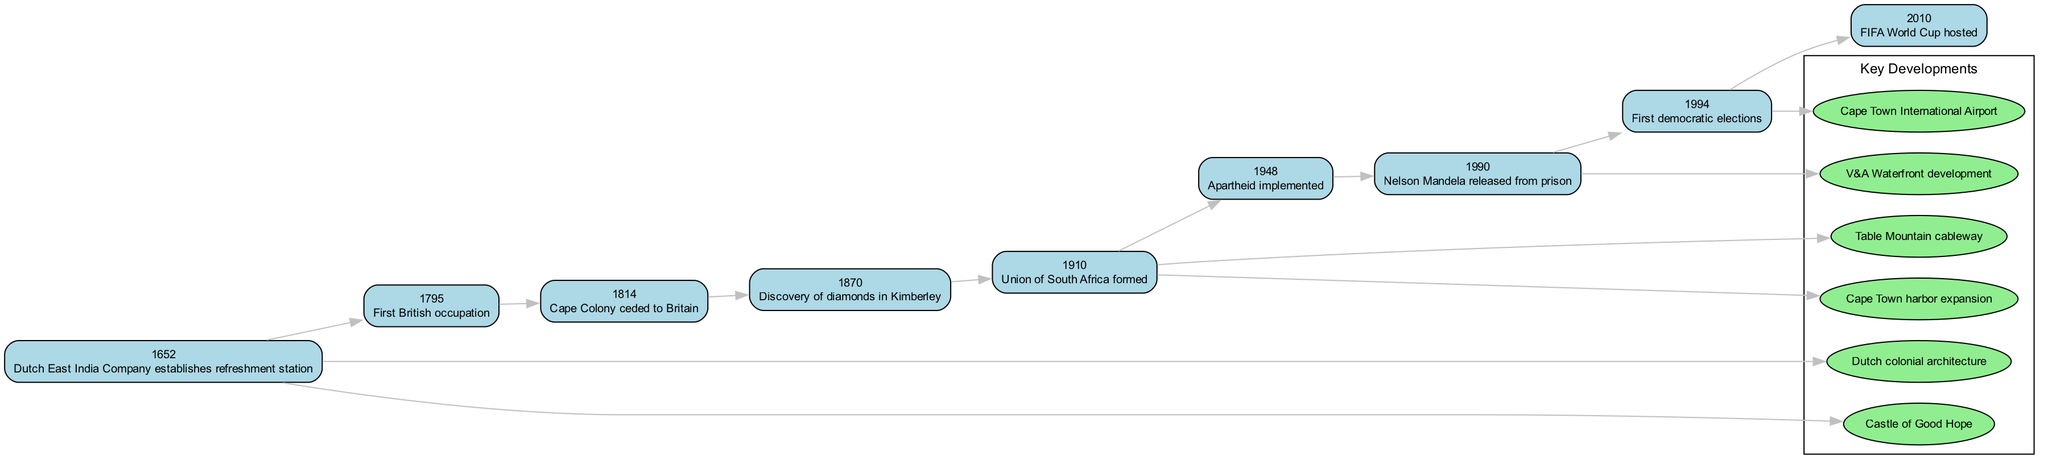What year did the Dutch East India Company establish the refreshment station? The event "Dutch East India Company establishes refreshment station" is linked to the year 1652 in the timeline.
Answer: 1652 Which event occurred first, the first British occupation or the discovery of diamonds in Kimberley? The timeline shows that the "First British occupation" happened in 1795 and the "Discovery of diamonds in Kimberley" occurred later in 1870. Therefore, the first event is the British occupation.
Answer: First British occupation How many key developments are listed in the diagram? There are six key developments mentioned in the diagram, as each one is represented in the key developments cluster.
Answer: 6 What event is directly linked to the year 1990 on the timeline? The timeline indicates that the event occurring in 1990 is "Nelson Mandela released from prison." This is directly marked under the year 1990.
Answer: Nelson Mandela released from prison Which key development is associated with the year 1910? The diagram connects two key developments to the year 1910: "Table Mountain cableway" and "Cape Town harbor expansion," indicating both developments are linked to this specific year.
Answer: Table Mountain cableway, Cape Town harbor expansion Explain the relationship between Apartheid and democratic elections in Cape Town's timeline. The timeline shows "Apartheid implemented" in 1948 and "First democratic elections" in 1994. This indicates a significant historical context where the implementation of apartheid paved the way for a long struggle, leading to the eventual democratic elections many years later.
Answer: Apartheid implemented led to First democratic elections Which event took place immediately after the Union of South Africa was formed? The event that comes right after "Union of South Africa formed" in 1910 is the implementation of apartheid in 1948. The timeline connects these two events sequentially, showcasing the historical progression.
Answer: Apartheid implemented What is the last event shown in the timeline? According to the timeline, the final event listed is "FIFA World Cup hosted," which occurred in the year 2010.
Answer: FIFA World Cup hosted 